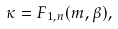Convert formula to latex. <formula><loc_0><loc_0><loc_500><loc_500>\kappa = F _ { 1 , n } ( m , \beta ) ,</formula> 